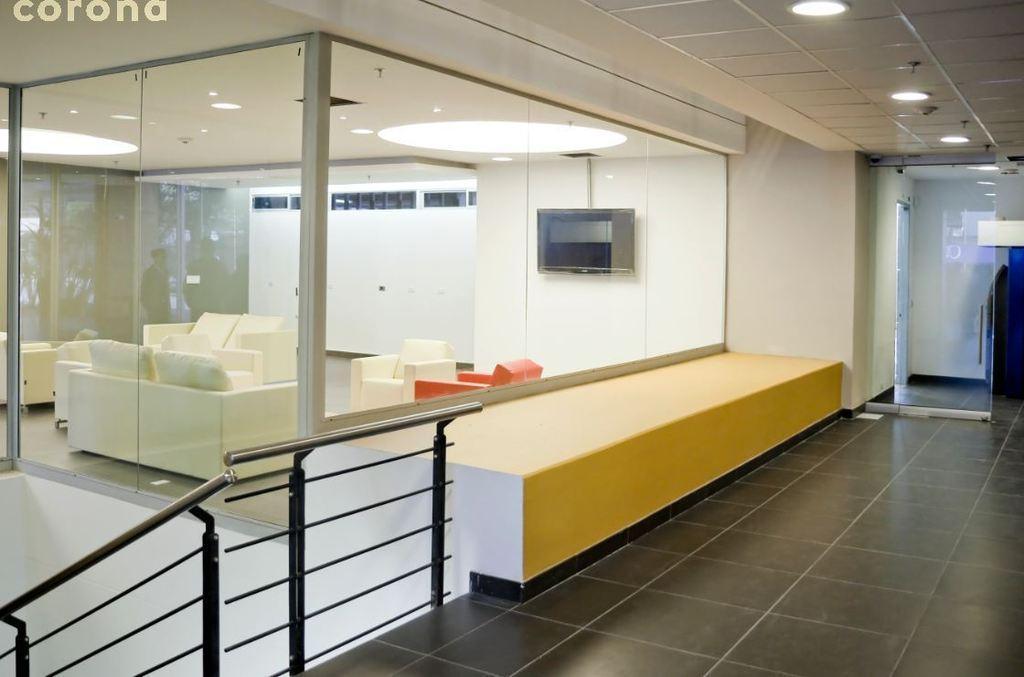How would you summarize this image in a sentence or two? there is a building in which there is a room which has white sofas. behind that there are white wall on which there is a television. above that there are lights. at the right there is a glass door. at the left there are black fencing and stairs. 